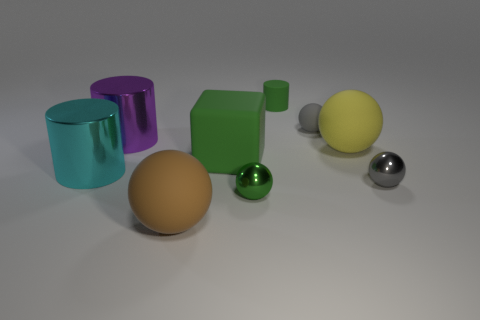There is a rubber thing that is both behind the small green metallic thing and to the left of the green sphere; what shape is it?
Offer a terse response. Cube. Are there any green rubber objects in front of the tiny green matte object?
Your answer should be compact. Yes. Is there anything else that has the same shape as the large brown object?
Provide a succinct answer. Yes. Do the large cyan thing and the large purple shiny thing have the same shape?
Ensure brevity in your answer.  Yes. Are there the same number of gray rubber things that are right of the yellow rubber sphere and purple metal objects that are behind the tiny green rubber cylinder?
Your response must be concise. Yes. What number of other objects are the same material as the green cylinder?
Your answer should be very brief. 4. What number of big things are purple metallic cylinders or green things?
Ensure brevity in your answer.  2. Are there the same number of large brown rubber objects that are behind the large purple object and tiny gray metal things?
Offer a very short reply. No. Is there a tiny green matte cylinder in front of the metal object to the right of the tiny rubber sphere?
Your answer should be compact. No. How many other objects are there of the same color as the block?
Make the answer very short. 2. 